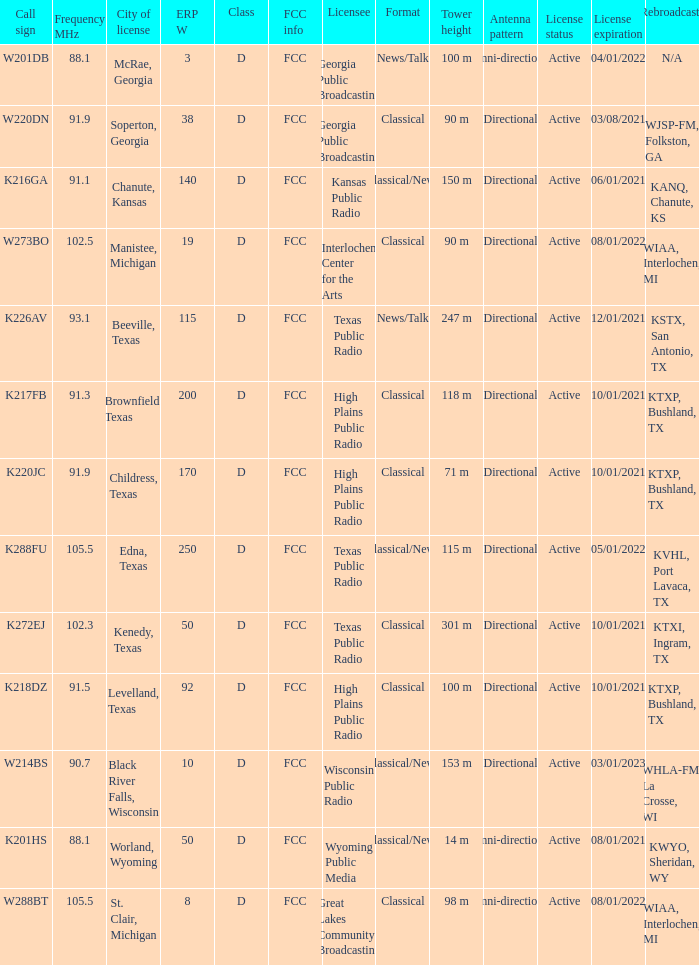What is the Sum of ERP W, when Call Sign is K216GA? 140.0. 